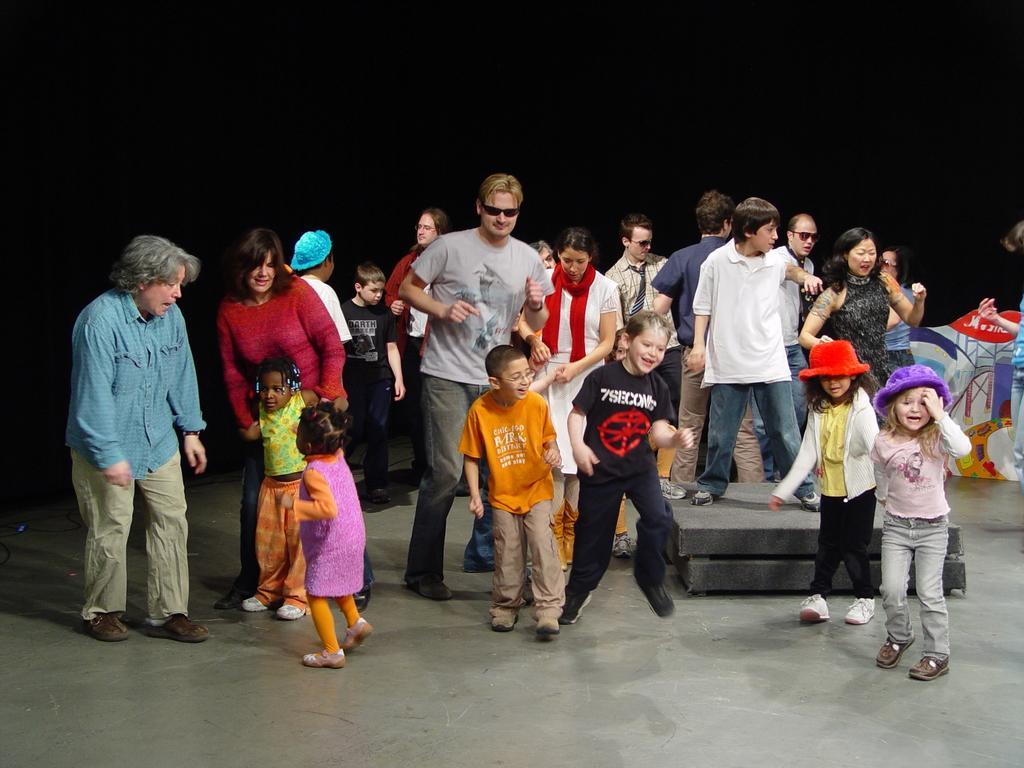Can you describe this image briefly? In this image we can see so many people are standing, some objects are on the surface and some children are dancing. 